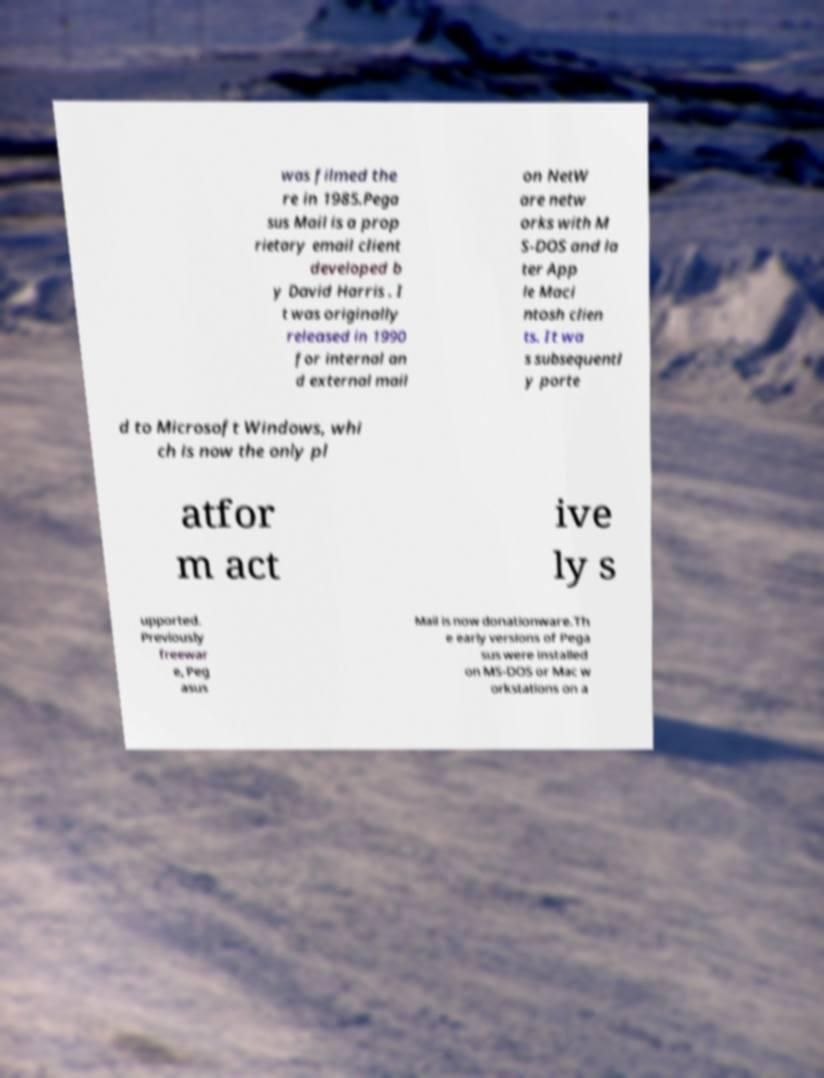Please identify and transcribe the text found in this image. was filmed the re in 1985.Pega sus Mail is a prop rietary email client developed b y David Harris . I t was originally released in 1990 for internal an d external mail on NetW are netw orks with M S-DOS and la ter App le Maci ntosh clien ts. It wa s subsequentl y porte d to Microsoft Windows, whi ch is now the only pl atfor m act ive ly s upported. Previously freewar e, Peg asus Mail is now donationware.Th e early versions of Pega sus were installed on MS-DOS or Mac w orkstations on a 